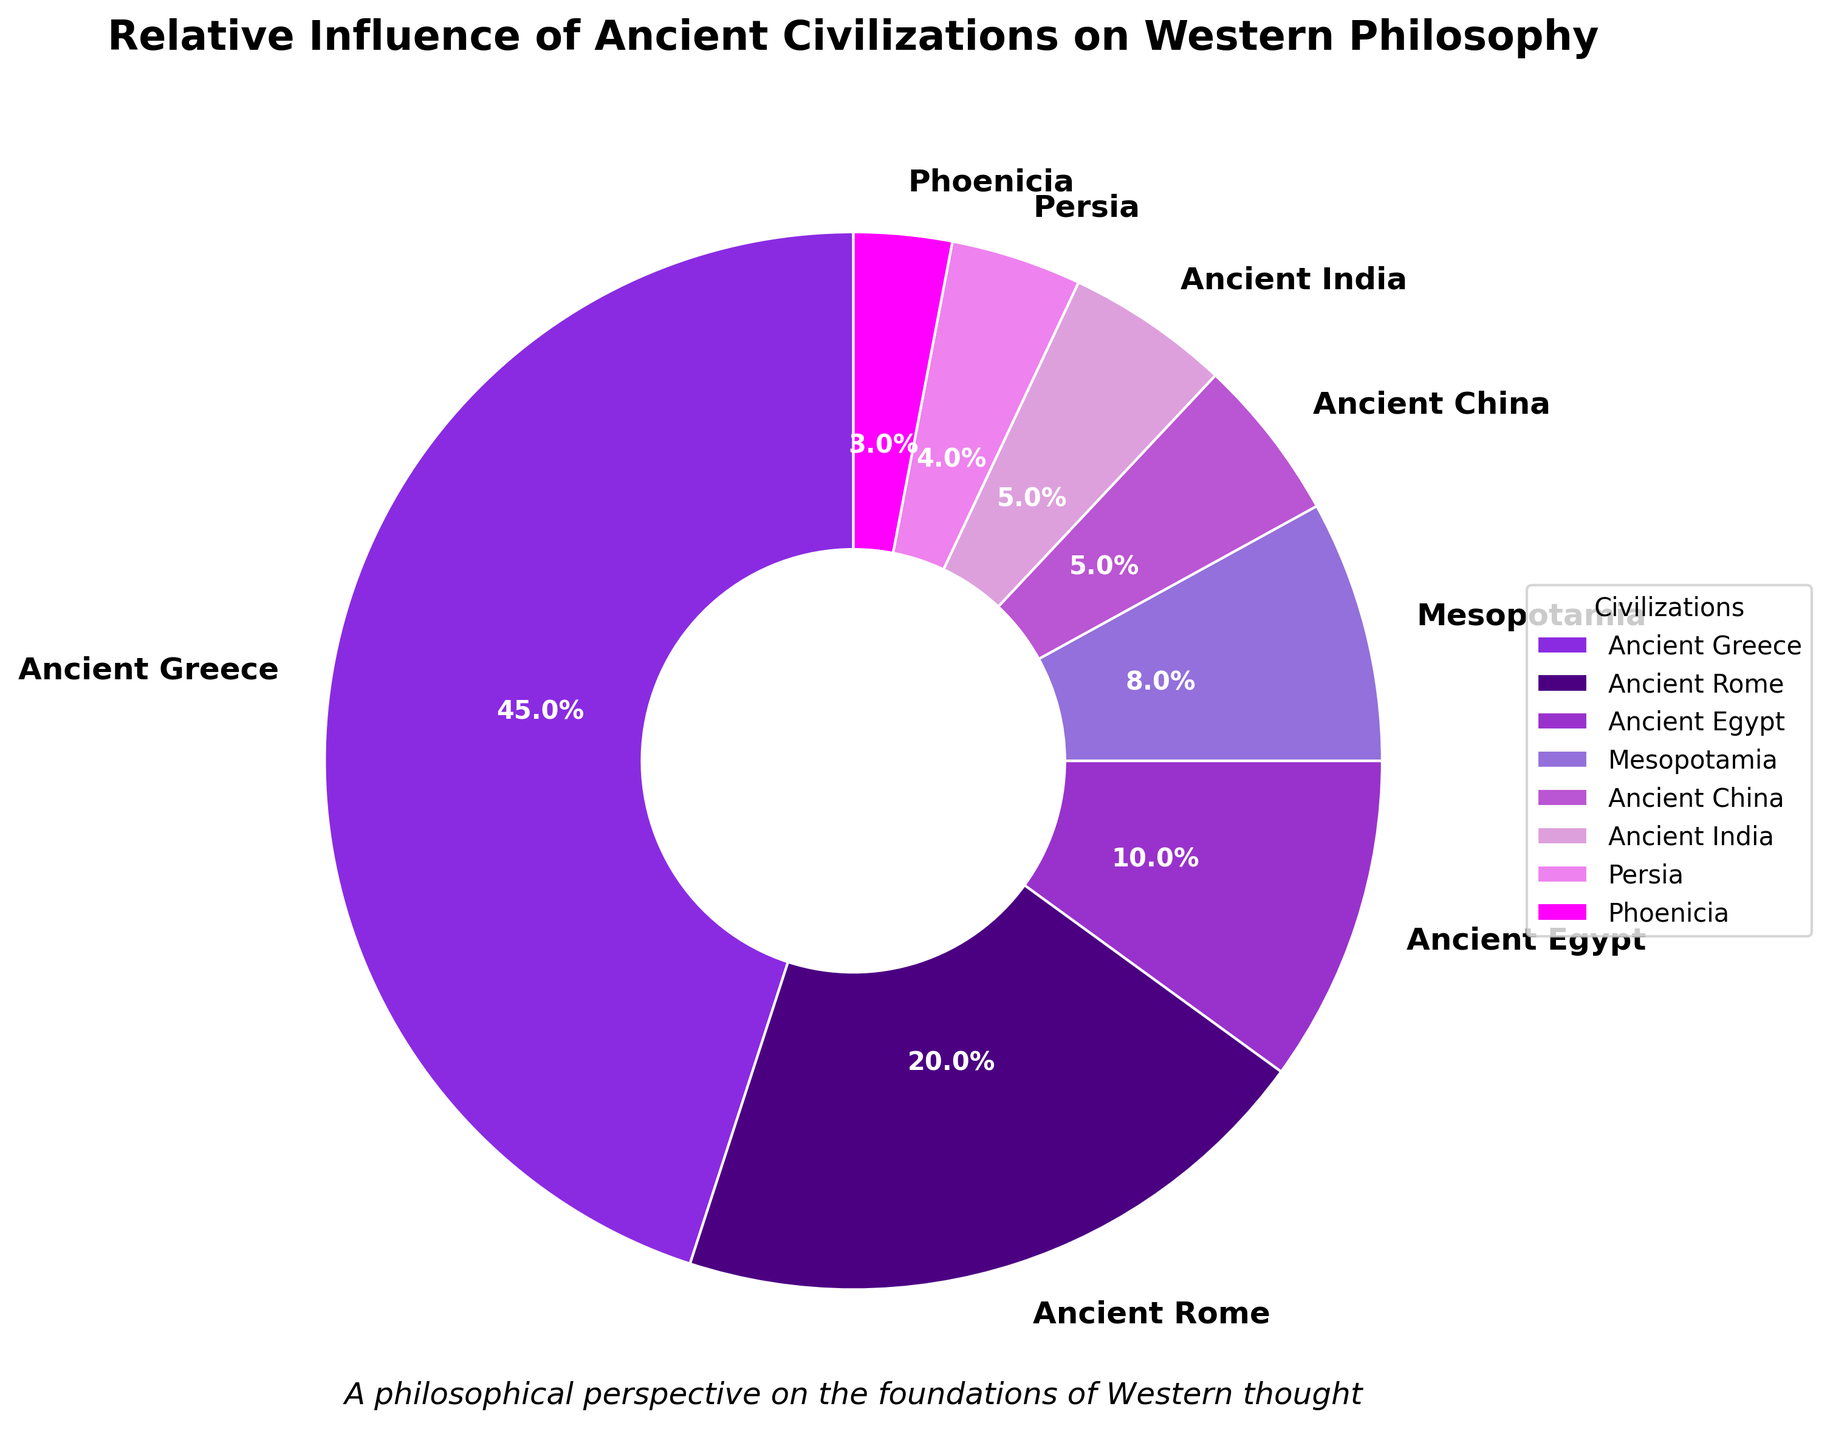What percentage of total influence do Ancient Greece and Ancient Rome have together? The influence percentage of Ancient Greece is 45% and Ancient Rome is 20%. Sum them up: 45% + 20% = 65%
Answer: 65% Which civilization has the highest influence on Western philosophy? Look at the pie chart's segments and labels. The segment with the largest area and the label "Ancient Greece" indicates it has the highest influence with 45%.
Answer: Ancient Greece How does the influence percentage of Ancient Egypt compare to that of Persia? Ancient Egypt has an influence percentage of 10%, while Persia has 4%. Comparing these values, Ancient Egypt's influence is greater than Persia's.
Answer: Ancient Egypt has greater influence What is the combined influence percentage of Ancient China and Ancient India? Ancient China has an influence percentage of 5%, and Ancient India also has 5%. Sum them up: 5% + 5% = 10%
Answer: 10% What is the difference in influence between Mesopotamia and Phoenicia? Mesopotamia has an 8% influence, and Phoenicia has 3%. Subtract these values: 8% - 3% = 5%
Answer: 5% Which civilizations have influence percentages that are less than 10%? Looking at the pie chart, Ancient Egypt (10%) is excluded. Mesopotamia (8%), Ancient China (5%), Ancient India (5%), Persia (4%), and Phoenicia (3%) all have less than 10%.
Answer: Mesopotamia, Ancient China, Ancient India, Persia, Phoenicia If we were to combine the influences of all civilizations except Ancient Greece, what would be the total percentage? Sum up the values excluding Ancient Greece (45%): 20% (Ancient Rome) + 10% (Ancient Egypt) + 8% (Mesopotamia) + 5% (Ancient China) + 5% (Ancient India) + 4% (Persia) + 3% (Phoenicia) = 55%
Answer: 55% Which civilizations contribute the smallest influences and what are their corresponding percentages? From the pie chart, the smallest contributors are Persia with 4% and Phoenicia with 3%.
Answer: Persia (4%), Phoenicia (3%) How much larger is the influence of Ancient Greece compared to the combined influence of Ancient China and Ancient India? Ancient Greece's influence is 45%. Combined influence of Ancient China and Ancient India is 10%. Calculating the difference: 45% - 10% = 35%
Answer: 35% What color represents Ancient Egypt in the pie chart? Identify the segment labeled "Ancient Egypt" in the pie chart. It is represented by a specific color, described as '#9370DB', which translates to a lighter purple.
Answer: Light purple 